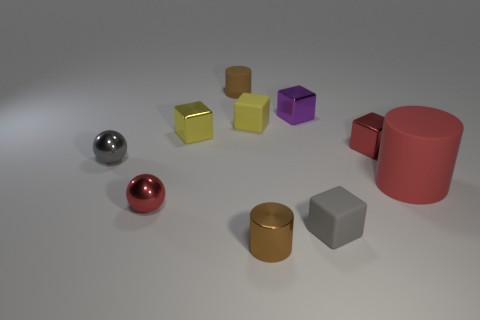Subtract all shiny cylinders. How many cylinders are left? 2 Subtract 1 spheres. How many spheres are left? 1 Subtract all red blocks. How many blocks are left? 4 Add 5 cubes. How many cubes exist? 10 Subtract 1 yellow cubes. How many objects are left? 9 Subtract all spheres. How many objects are left? 8 Subtract all blue spheres. Subtract all brown cubes. How many spheres are left? 2 Subtract all brown balls. How many brown cylinders are left? 2 Subtract all big gray things. Subtract all shiny cylinders. How many objects are left? 9 Add 1 yellow metallic objects. How many yellow metallic objects are left? 2 